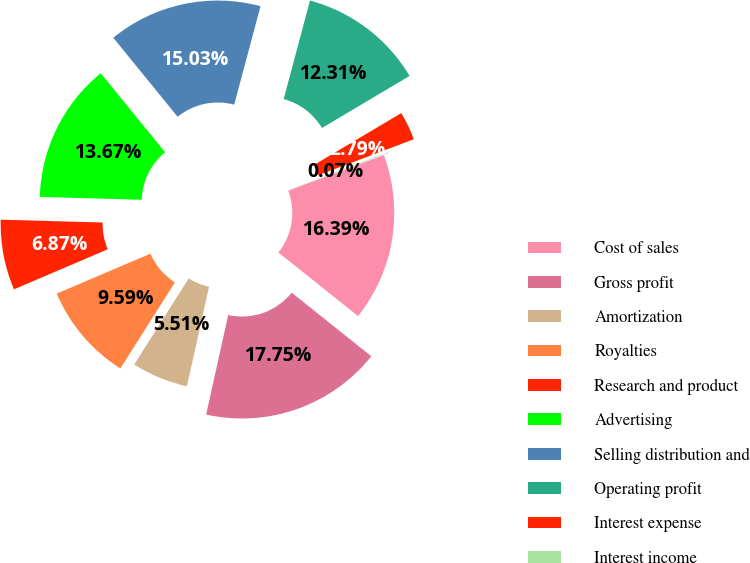Convert chart to OTSL. <chart><loc_0><loc_0><loc_500><loc_500><pie_chart><fcel>Cost of sales<fcel>Gross profit<fcel>Amortization<fcel>Royalties<fcel>Research and product<fcel>Advertising<fcel>Selling distribution and<fcel>Operating profit<fcel>Interest expense<fcel>Interest income<nl><fcel>16.39%<fcel>17.75%<fcel>5.51%<fcel>9.59%<fcel>6.87%<fcel>13.67%<fcel>15.03%<fcel>12.31%<fcel>2.79%<fcel>0.07%<nl></chart> 